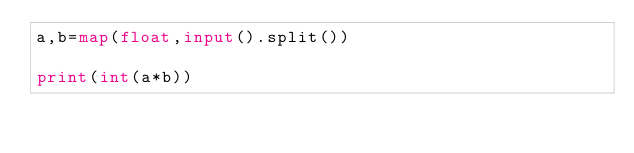<code> <loc_0><loc_0><loc_500><loc_500><_Python_>a,b=map(float,input().split())

print(int(a*b))</code> 